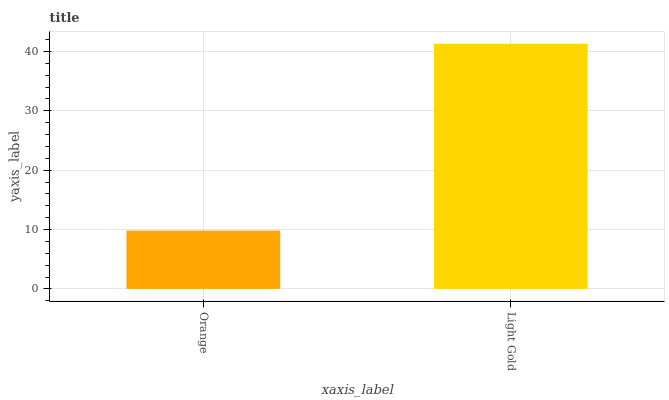Is Orange the minimum?
Answer yes or no. Yes. Is Light Gold the maximum?
Answer yes or no. Yes. Is Light Gold the minimum?
Answer yes or no. No. Is Light Gold greater than Orange?
Answer yes or no. Yes. Is Orange less than Light Gold?
Answer yes or no. Yes. Is Orange greater than Light Gold?
Answer yes or no. No. Is Light Gold less than Orange?
Answer yes or no. No. Is Light Gold the high median?
Answer yes or no. Yes. Is Orange the low median?
Answer yes or no. Yes. Is Orange the high median?
Answer yes or no. No. Is Light Gold the low median?
Answer yes or no. No. 